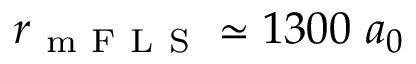<formula> <loc_0><loc_0><loc_500><loc_500>r _ { m F L S } \simeq 1 3 0 0 \ a _ { 0 }</formula> 